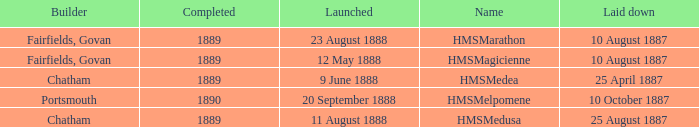Give me the full table as a dictionary. {'header': ['Builder', 'Completed', 'Launched', 'Name', 'Laid down'], 'rows': [['Fairfields, Govan', '1889', '23 August 1888', 'HMSMarathon', '10 August 1887'], ['Fairfields, Govan', '1889', '12 May 1888', 'HMSMagicienne', '10 August 1887'], ['Chatham', '1889', '9 June 1888', 'HMSMedea', '25 April 1887'], ['Portsmouth', '1890', '20 September 1888', 'HMSMelpomene', '10 October 1887'], ['Chatham', '1889', '11 August 1888', 'HMSMedusa', '25 August 1887']]} What is the name of the boat that was built by Chatham and Laid down of 25 april 1887? HMSMedea. 